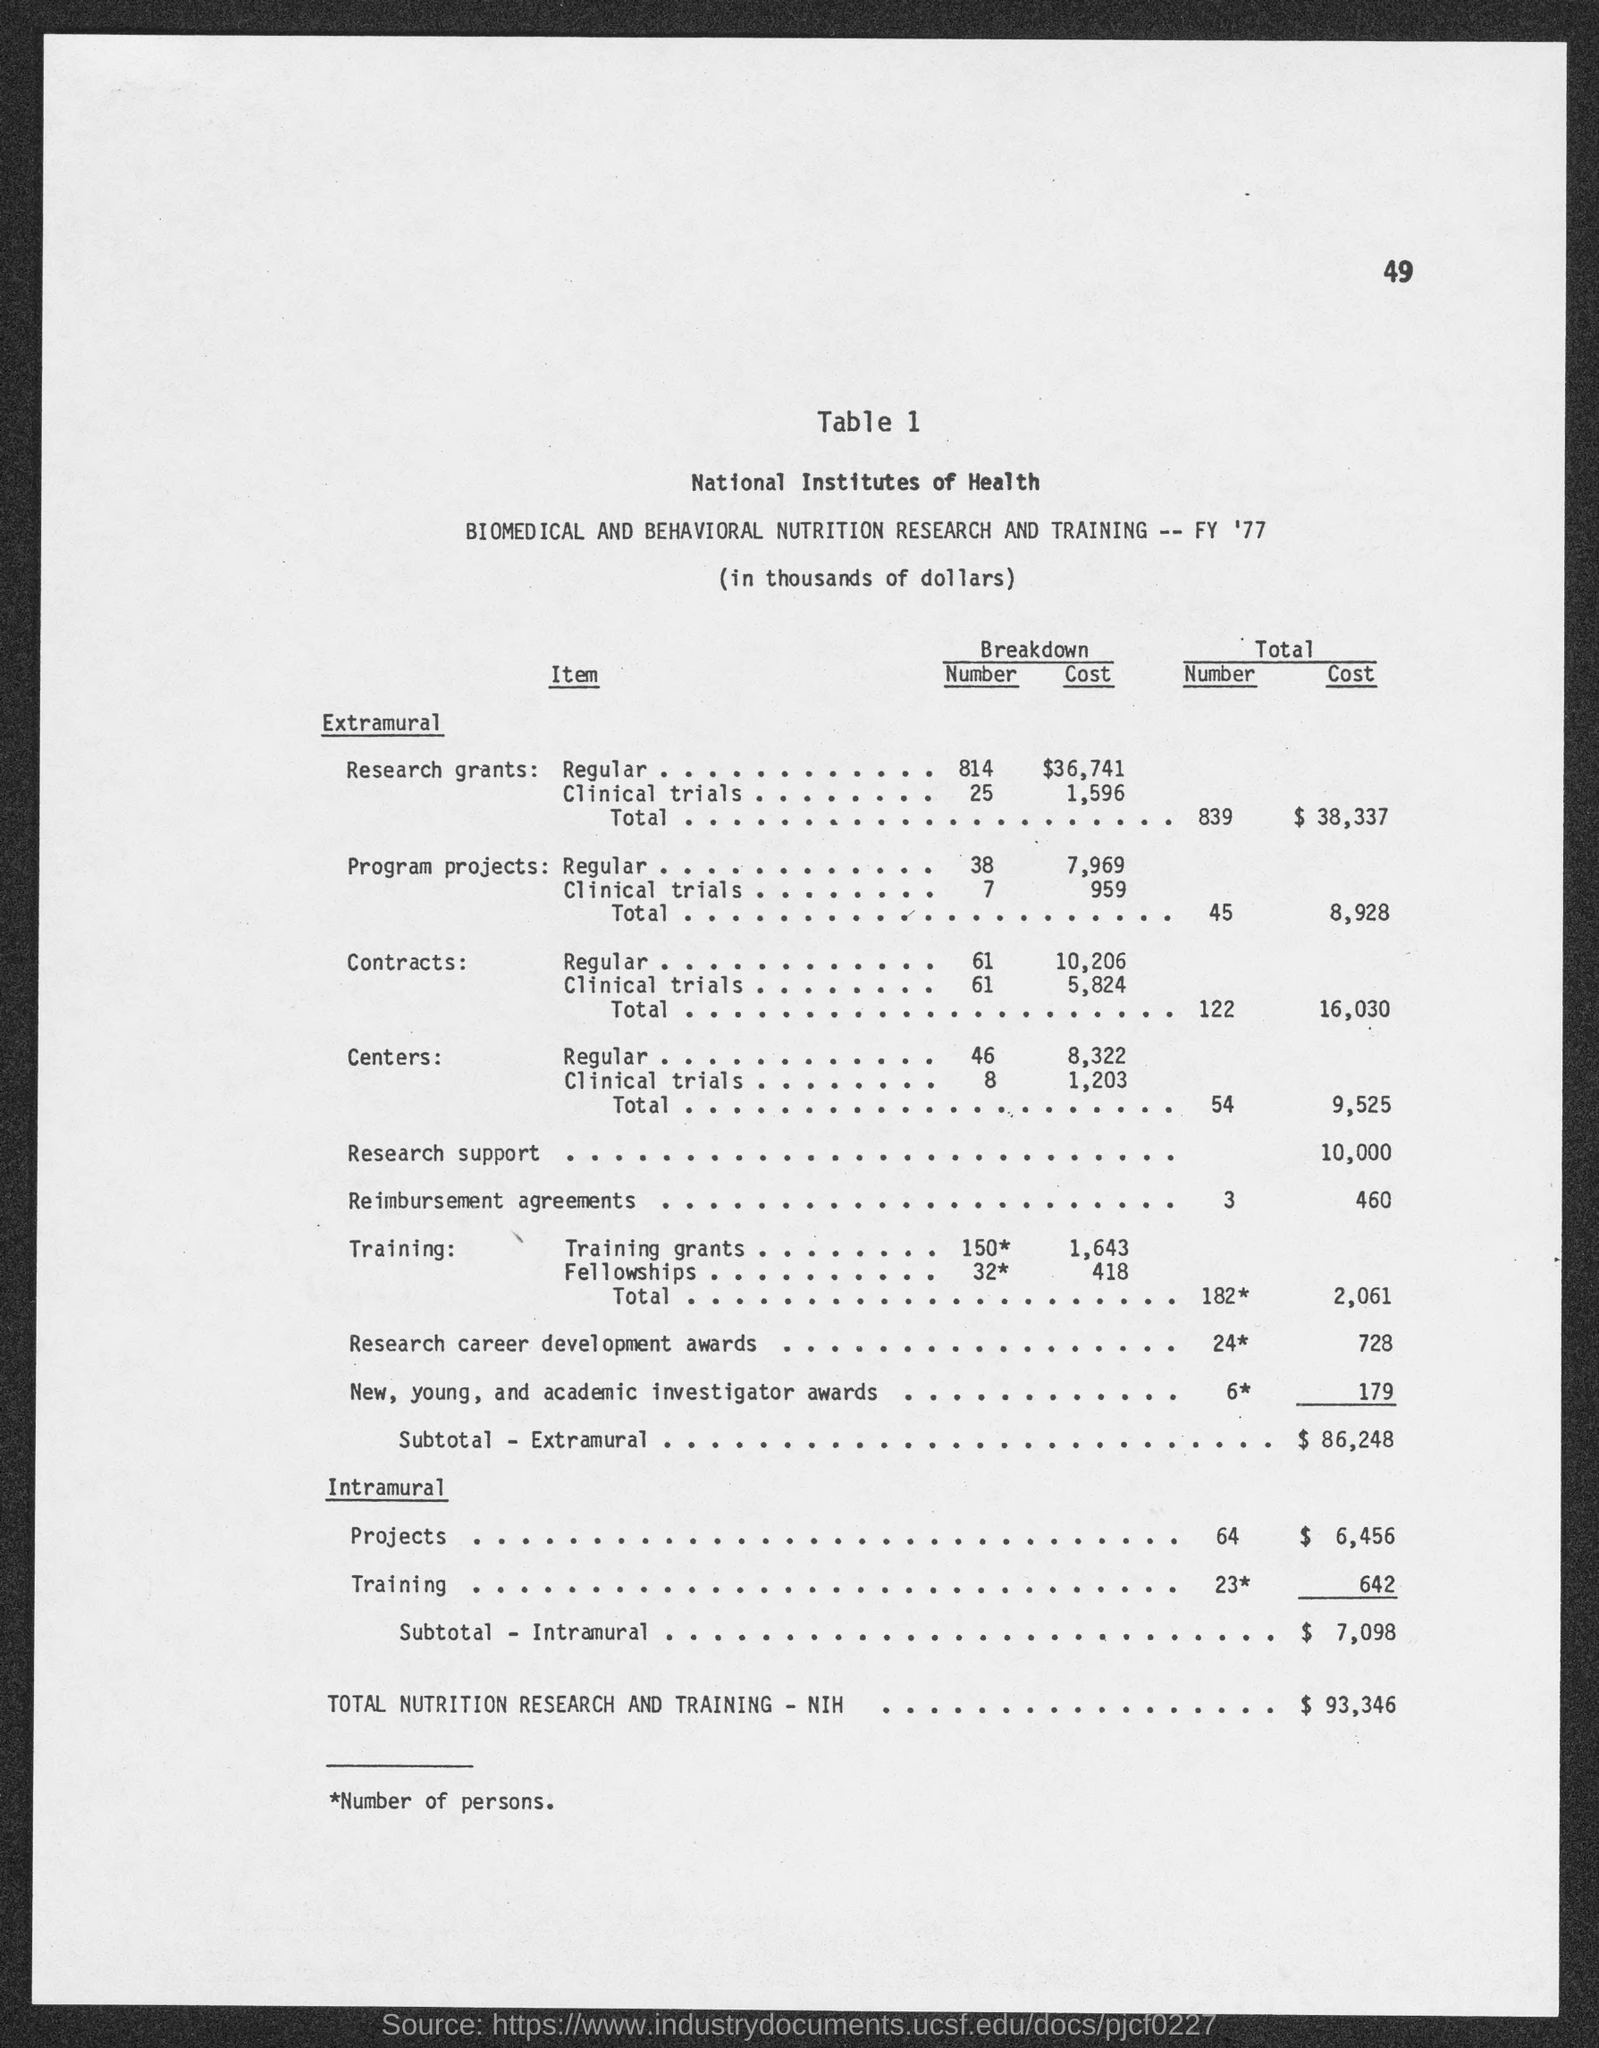Mention a couple of crucial points in this snapshot. The total cost of Reimbursement Agreements is $460. The total cost of Program Projects is $8,928. The total cost of Contracts is $16,030. The total cost of centers is $9,525. The subtotal cost of extramural activities is $86,248. 